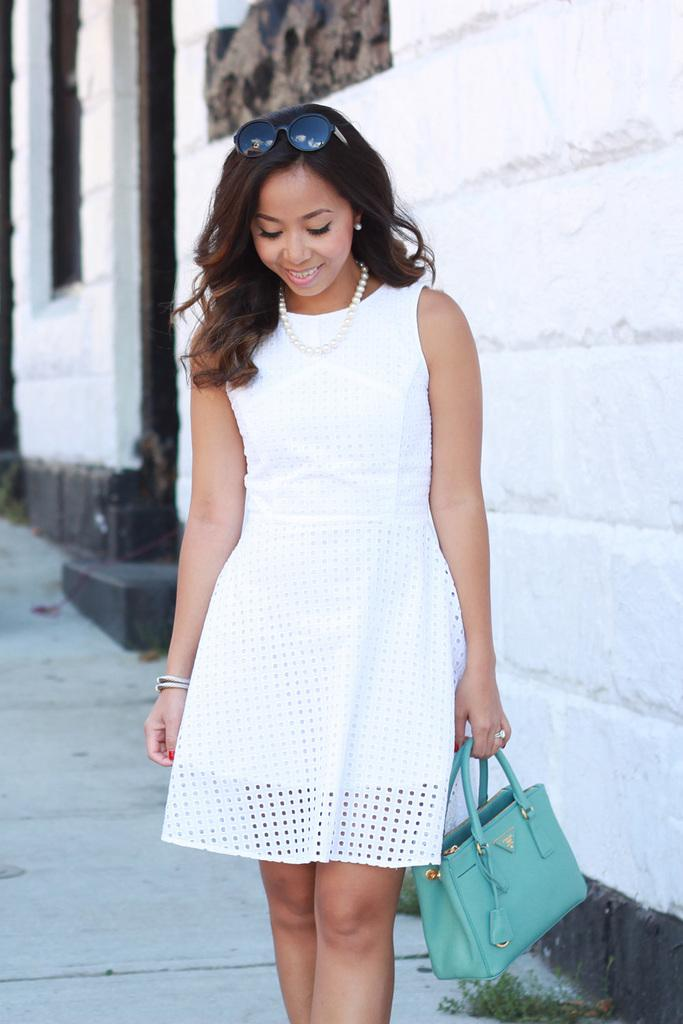Who is present in the image? There is a woman in the image. What is the woman doing in the image? The woman is standing on the ground in the image. What is the woman holding in the image? The woman is holding a handbag in the image. What accessory is the woman wearing in the image? The woman is wearing glasses on her head in the image. What can be seen in the background of the image? There is a wall in the background of the image. What things are being wasted in the image? There is no indication of waste or things being wasted in the image. 